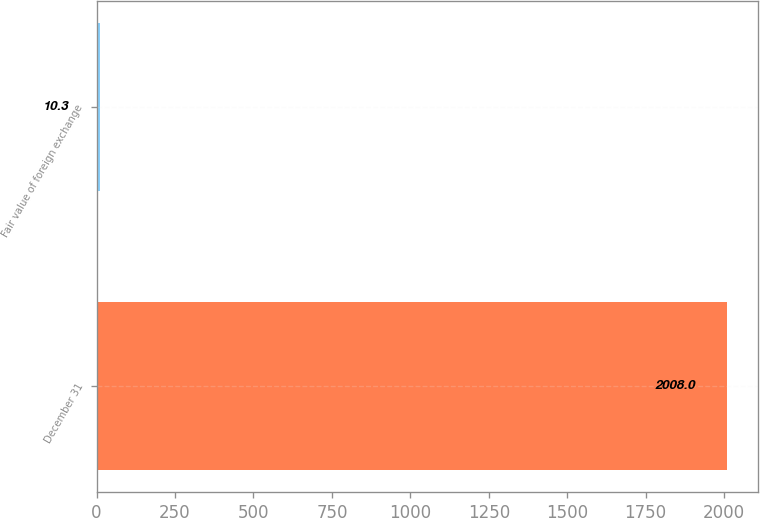Convert chart to OTSL. <chart><loc_0><loc_0><loc_500><loc_500><bar_chart><fcel>December 31<fcel>Fair value of foreign exchange<nl><fcel>2008<fcel>10.3<nl></chart> 